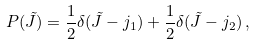<formula> <loc_0><loc_0><loc_500><loc_500>P ( \tilde { J } ) = \frac { 1 } { 2 } \delta ( \tilde { J } - j _ { 1 } ) + \frac { 1 } { 2 } \delta ( \tilde { J } - j _ { 2 } ) \, ,</formula> 